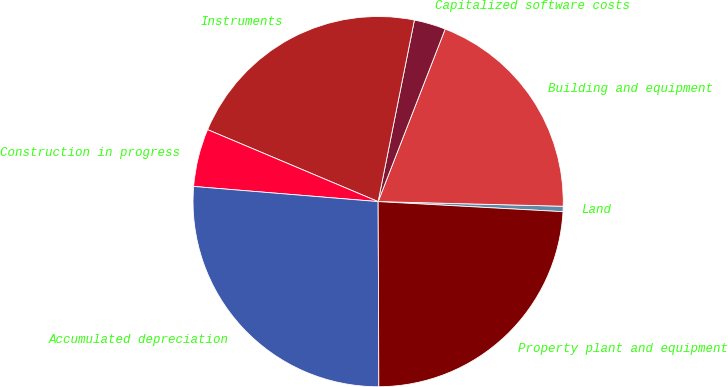Convert chart. <chart><loc_0><loc_0><loc_500><loc_500><pie_chart><fcel>Land<fcel>Building and equipment<fcel>Capitalized software costs<fcel>Instruments<fcel>Construction in progress<fcel>Accumulated depreciation<fcel>Property plant and equipment<nl><fcel>0.47%<fcel>19.5%<fcel>2.76%<fcel>21.78%<fcel>5.05%<fcel>26.36%<fcel>24.07%<nl></chart> 